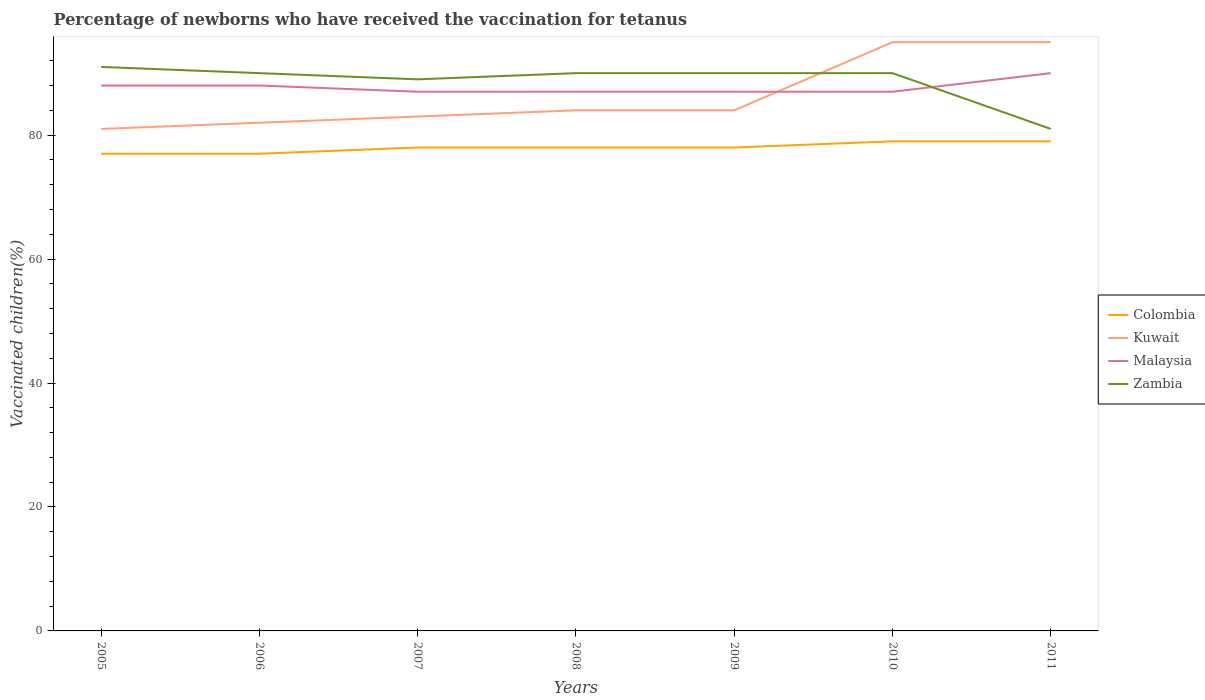Is the number of lines equal to the number of legend labels?
Keep it short and to the point. Yes. What is the total percentage of vaccinated children in Zambia in the graph?
Keep it short and to the point. 9. What is the difference between the highest and the second highest percentage of vaccinated children in Colombia?
Give a very brief answer. 2. Is the percentage of vaccinated children in Malaysia strictly greater than the percentage of vaccinated children in Colombia over the years?
Make the answer very short. No. How many years are there in the graph?
Keep it short and to the point. 7. What is the difference between two consecutive major ticks on the Y-axis?
Give a very brief answer. 20. Are the values on the major ticks of Y-axis written in scientific E-notation?
Offer a very short reply. No. Does the graph contain any zero values?
Offer a terse response. No. Does the graph contain grids?
Your answer should be very brief. No. How are the legend labels stacked?
Your answer should be compact. Vertical. What is the title of the graph?
Offer a terse response. Percentage of newborns who have received the vaccination for tetanus. What is the label or title of the Y-axis?
Offer a very short reply. Vaccinated children(%). What is the Vaccinated children(%) in Colombia in 2005?
Offer a very short reply. 77. What is the Vaccinated children(%) in Kuwait in 2005?
Make the answer very short. 81. What is the Vaccinated children(%) of Zambia in 2005?
Offer a very short reply. 91. What is the Vaccinated children(%) in Malaysia in 2006?
Offer a terse response. 88. What is the Vaccinated children(%) in Zambia in 2006?
Your answer should be compact. 90. What is the Vaccinated children(%) of Colombia in 2007?
Provide a succinct answer. 78. What is the Vaccinated children(%) of Kuwait in 2007?
Make the answer very short. 83. What is the Vaccinated children(%) in Zambia in 2007?
Give a very brief answer. 89. What is the Vaccinated children(%) in Kuwait in 2008?
Your answer should be compact. 84. What is the Vaccinated children(%) of Malaysia in 2008?
Make the answer very short. 87. What is the Vaccinated children(%) of Colombia in 2009?
Provide a succinct answer. 78. What is the Vaccinated children(%) in Kuwait in 2009?
Your answer should be very brief. 84. What is the Vaccinated children(%) of Malaysia in 2009?
Your response must be concise. 87. What is the Vaccinated children(%) of Zambia in 2009?
Offer a very short reply. 90. What is the Vaccinated children(%) in Colombia in 2010?
Offer a very short reply. 79. What is the Vaccinated children(%) of Colombia in 2011?
Offer a terse response. 79. What is the Vaccinated children(%) of Zambia in 2011?
Give a very brief answer. 81. Across all years, what is the maximum Vaccinated children(%) in Colombia?
Provide a short and direct response. 79. Across all years, what is the maximum Vaccinated children(%) of Malaysia?
Provide a short and direct response. 90. Across all years, what is the maximum Vaccinated children(%) of Zambia?
Your answer should be very brief. 91. Across all years, what is the minimum Vaccinated children(%) in Kuwait?
Offer a very short reply. 81. Across all years, what is the minimum Vaccinated children(%) in Malaysia?
Keep it short and to the point. 87. Across all years, what is the minimum Vaccinated children(%) in Zambia?
Offer a very short reply. 81. What is the total Vaccinated children(%) of Colombia in the graph?
Your response must be concise. 546. What is the total Vaccinated children(%) of Kuwait in the graph?
Your answer should be very brief. 604. What is the total Vaccinated children(%) of Malaysia in the graph?
Provide a short and direct response. 614. What is the total Vaccinated children(%) of Zambia in the graph?
Offer a very short reply. 621. What is the difference between the Vaccinated children(%) of Malaysia in 2005 and that in 2006?
Provide a short and direct response. 0. What is the difference between the Vaccinated children(%) in Zambia in 2005 and that in 2006?
Give a very brief answer. 1. What is the difference between the Vaccinated children(%) of Kuwait in 2005 and that in 2007?
Provide a succinct answer. -2. What is the difference between the Vaccinated children(%) in Zambia in 2005 and that in 2007?
Your answer should be compact. 2. What is the difference between the Vaccinated children(%) in Colombia in 2005 and that in 2008?
Your answer should be compact. -1. What is the difference between the Vaccinated children(%) of Kuwait in 2005 and that in 2008?
Your answer should be very brief. -3. What is the difference between the Vaccinated children(%) of Zambia in 2005 and that in 2008?
Your answer should be very brief. 1. What is the difference between the Vaccinated children(%) of Colombia in 2005 and that in 2009?
Your answer should be compact. -1. What is the difference between the Vaccinated children(%) of Colombia in 2005 and that in 2010?
Offer a very short reply. -2. What is the difference between the Vaccinated children(%) of Zambia in 2005 and that in 2010?
Give a very brief answer. 1. What is the difference between the Vaccinated children(%) of Malaysia in 2005 and that in 2011?
Offer a terse response. -2. What is the difference between the Vaccinated children(%) of Zambia in 2005 and that in 2011?
Provide a succinct answer. 10. What is the difference between the Vaccinated children(%) of Zambia in 2006 and that in 2007?
Ensure brevity in your answer.  1. What is the difference between the Vaccinated children(%) of Malaysia in 2006 and that in 2008?
Keep it short and to the point. 1. What is the difference between the Vaccinated children(%) of Zambia in 2006 and that in 2008?
Your answer should be very brief. 0. What is the difference between the Vaccinated children(%) of Colombia in 2006 and that in 2009?
Your answer should be very brief. -1. What is the difference between the Vaccinated children(%) in Zambia in 2006 and that in 2009?
Your answer should be compact. 0. What is the difference between the Vaccinated children(%) in Malaysia in 2006 and that in 2010?
Keep it short and to the point. 1. What is the difference between the Vaccinated children(%) of Colombia in 2006 and that in 2011?
Ensure brevity in your answer.  -2. What is the difference between the Vaccinated children(%) of Malaysia in 2006 and that in 2011?
Make the answer very short. -2. What is the difference between the Vaccinated children(%) in Zambia in 2006 and that in 2011?
Offer a terse response. 9. What is the difference between the Vaccinated children(%) in Colombia in 2007 and that in 2008?
Your answer should be very brief. 0. What is the difference between the Vaccinated children(%) in Kuwait in 2007 and that in 2008?
Provide a succinct answer. -1. What is the difference between the Vaccinated children(%) of Zambia in 2007 and that in 2008?
Your response must be concise. -1. What is the difference between the Vaccinated children(%) in Kuwait in 2007 and that in 2009?
Provide a succinct answer. -1. What is the difference between the Vaccinated children(%) in Malaysia in 2007 and that in 2010?
Ensure brevity in your answer.  0. What is the difference between the Vaccinated children(%) of Zambia in 2007 and that in 2010?
Give a very brief answer. -1. What is the difference between the Vaccinated children(%) of Malaysia in 2007 and that in 2011?
Your answer should be compact. -3. What is the difference between the Vaccinated children(%) in Zambia in 2007 and that in 2011?
Your answer should be compact. 8. What is the difference between the Vaccinated children(%) of Colombia in 2008 and that in 2009?
Offer a very short reply. 0. What is the difference between the Vaccinated children(%) of Malaysia in 2008 and that in 2009?
Your answer should be compact. 0. What is the difference between the Vaccinated children(%) of Colombia in 2008 and that in 2010?
Offer a very short reply. -1. What is the difference between the Vaccinated children(%) of Kuwait in 2008 and that in 2010?
Your response must be concise. -11. What is the difference between the Vaccinated children(%) in Kuwait in 2008 and that in 2011?
Give a very brief answer. -11. What is the difference between the Vaccinated children(%) of Malaysia in 2008 and that in 2011?
Provide a succinct answer. -3. What is the difference between the Vaccinated children(%) of Kuwait in 2009 and that in 2010?
Provide a short and direct response. -11. What is the difference between the Vaccinated children(%) of Malaysia in 2009 and that in 2010?
Ensure brevity in your answer.  0. What is the difference between the Vaccinated children(%) of Zambia in 2009 and that in 2010?
Offer a very short reply. 0. What is the difference between the Vaccinated children(%) of Colombia in 2009 and that in 2011?
Your answer should be compact. -1. What is the difference between the Vaccinated children(%) of Malaysia in 2010 and that in 2011?
Ensure brevity in your answer.  -3. What is the difference between the Vaccinated children(%) of Colombia in 2005 and the Vaccinated children(%) of Malaysia in 2006?
Your answer should be very brief. -11. What is the difference between the Vaccinated children(%) of Kuwait in 2005 and the Vaccinated children(%) of Malaysia in 2006?
Provide a succinct answer. -7. What is the difference between the Vaccinated children(%) in Colombia in 2005 and the Vaccinated children(%) in Kuwait in 2007?
Your answer should be very brief. -6. What is the difference between the Vaccinated children(%) of Colombia in 2005 and the Vaccinated children(%) of Malaysia in 2007?
Keep it short and to the point. -10. What is the difference between the Vaccinated children(%) in Colombia in 2005 and the Vaccinated children(%) in Zambia in 2007?
Offer a very short reply. -12. What is the difference between the Vaccinated children(%) of Kuwait in 2005 and the Vaccinated children(%) of Malaysia in 2007?
Give a very brief answer. -6. What is the difference between the Vaccinated children(%) in Colombia in 2005 and the Vaccinated children(%) in Malaysia in 2008?
Keep it short and to the point. -10. What is the difference between the Vaccinated children(%) of Malaysia in 2005 and the Vaccinated children(%) of Zambia in 2008?
Your response must be concise. -2. What is the difference between the Vaccinated children(%) of Kuwait in 2005 and the Vaccinated children(%) of Zambia in 2009?
Offer a terse response. -9. What is the difference between the Vaccinated children(%) in Colombia in 2005 and the Vaccinated children(%) in Kuwait in 2010?
Make the answer very short. -18. What is the difference between the Vaccinated children(%) in Colombia in 2005 and the Vaccinated children(%) in Malaysia in 2010?
Make the answer very short. -10. What is the difference between the Vaccinated children(%) in Colombia in 2005 and the Vaccinated children(%) in Zambia in 2010?
Keep it short and to the point. -13. What is the difference between the Vaccinated children(%) in Kuwait in 2005 and the Vaccinated children(%) in Zambia in 2010?
Offer a terse response. -9. What is the difference between the Vaccinated children(%) in Colombia in 2005 and the Vaccinated children(%) in Kuwait in 2011?
Provide a short and direct response. -18. What is the difference between the Vaccinated children(%) in Malaysia in 2005 and the Vaccinated children(%) in Zambia in 2011?
Your answer should be very brief. 7. What is the difference between the Vaccinated children(%) of Colombia in 2006 and the Vaccinated children(%) of Malaysia in 2007?
Keep it short and to the point. -10. What is the difference between the Vaccinated children(%) in Colombia in 2006 and the Vaccinated children(%) in Zambia in 2007?
Offer a very short reply. -12. What is the difference between the Vaccinated children(%) of Kuwait in 2006 and the Vaccinated children(%) of Zambia in 2007?
Your answer should be compact. -7. What is the difference between the Vaccinated children(%) in Colombia in 2006 and the Vaccinated children(%) in Malaysia in 2008?
Keep it short and to the point. -10. What is the difference between the Vaccinated children(%) in Kuwait in 2006 and the Vaccinated children(%) in Zambia in 2008?
Your response must be concise. -8. What is the difference between the Vaccinated children(%) in Colombia in 2006 and the Vaccinated children(%) in Malaysia in 2009?
Give a very brief answer. -10. What is the difference between the Vaccinated children(%) in Kuwait in 2006 and the Vaccinated children(%) in Malaysia in 2009?
Keep it short and to the point. -5. What is the difference between the Vaccinated children(%) of Kuwait in 2006 and the Vaccinated children(%) of Zambia in 2009?
Your response must be concise. -8. What is the difference between the Vaccinated children(%) of Colombia in 2006 and the Vaccinated children(%) of Zambia in 2010?
Provide a succinct answer. -13. What is the difference between the Vaccinated children(%) in Colombia in 2006 and the Vaccinated children(%) in Kuwait in 2011?
Your answer should be compact. -18. What is the difference between the Vaccinated children(%) in Colombia in 2006 and the Vaccinated children(%) in Malaysia in 2011?
Give a very brief answer. -13. What is the difference between the Vaccinated children(%) in Malaysia in 2007 and the Vaccinated children(%) in Zambia in 2008?
Your response must be concise. -3. What is the difference between the Vaccinated children(%) in Colombia in 2007 and the Vaccinated children(%) in Kuwait in 2009?
Provide a succinct answer. -6. What is the difference between the Vaccinated children(%) in Kuwait in 2007 and the Vaccinated children(%) in Zambia in 2009?
Provide a succinct answer. -7. What is the difference between the Vaccinated children(%) in Malaysia in 2007 and the Vaccinated children(%) in Zambia in 2009?
Your answer should be very brief. -3. What is the difference between the Vaccinated children(%) of Colombia in 2007 and the Vaccinated children(%) of Malaysia in 2010?
Provide a short and direct response. -9. What is the difference between the Vaccinated children(%) in Colombia in 2007 and the Vaccinated children(%) in Kuwait in 2011?
Ensure brevity in your answer.  -17. What is the difference between the Vaccinated children(%) of Colombia in 2007 and the Vaccinated children(%) of Malaysia in 2011?
Provide a short and direct response. -12. What is the difference between the Vaccinated children(%) of Colombia in 2007 and the Vaccinated children(%) of Zambia in 2011?
Give a very brief answer. -3. What is the difference between the Vaccinated children(%) in Kuwait in 2007 and the Vaccinated children(%) in Zambia in 2011?
Offer a very short reply. 2. What is the difference between the Vaccinated children(%) of Malaysia in 2007 and the Vaccinated children(%) of Zambia in 2011?
Your answer should be very brief. 6. What is the difference between the Vaccinated children(%) in Colombia in 2008 and the Vaccinated children(%) in Zambia in 2009?
Ensure brevity in your answer.  -12. What is the difference between the Vaccinated children(%) of Kuwait in 2008 and the Vaccinated children(%) of Malaysia in 2009?
Give a very brief answer. -3. What is the difference between the Vaccinated children(%) of Colombia in 2008 and the Vaccinated children(%) of Zambia in 2010?
Offer a very short reply. -12. What is the difference between the Vaccinated children(%) in Kuwait in 2008 and the Vaccinated children(%) in Malaysia in 2010?
Offer a very short reply. -3. What is the difference between the Vaccinated children(%) in Malaysia in 2008 and the Vaccinated children(%) in Zambia in 2010?
Your answer should be compact. -3. What is the difference between the Vaccinated children(%) in Kuwait in 2008 and the Vaccinated children(%) in Zambia in 2011?
Your response must be concise. 3. What is the difference between the Vaccinated children(%) of Colombia in 2009 and the Vaccinated children(%) of Kuwait in 2010?
Your answer should be very brief. -17. What is the difference between the Vaccinated children(%) of Colombia in 2009 and the Vaccinated children(%) of Malaysia in 2010?
Offer a very short reply. -9. What is the difference between the Vaccinated children(%) of Colombia in 2009 and the Vaccinated children(%) of Zambia in 2010?
Give a very brief answer. -12. What is the difference between the Vaccinated children(%) in Kuwait in 2009 and the Vaccinated children(%) in Malaysia in 2010?
Provide a short and direct response. -3. What is the difference between the Vaccinated children(%) of Kuwait in 2009 and the Vaccinated children(%) of Zambia in 2010?
Give a very brief answer. -6. What is the difference between the Vaccinated children(%) in Malaysia in 2009 and the Vaccinated children(%) in Zambia in 2010?
Offer a very short reply. -3. What is the difference between the Vaccinated children(%) in Colombia in 2009 and the Vaccinated children(%) in Kuwait in 2011?
Keep it short and to the point. -17. What is the difference between the Vaccinated children(%) of Colombia in 2009 and the Vaccinated children(%) of Malaysia in 2011?
Offer a terse response. -12. What is the difference between the Vaccinated children(%) of Colombia in 2010 and the Vaccinated children(%) of Kuwait in 2011?
Ensure brevity in your answer.  -16. What is the difference between the Vaccinated children(%) in Colombia in 2010 and the Vaccinated children(%) in Malaysia in 2011?
Your answer should be very brief. -11. What is the difference between the Vaccinated children(%) in Colombia in 2010 and the Vaccinated children(%) in Zambia in 2011?
Make the answer very short. -2. What is the difference between the Vaccinated children(%) of Kuwait in 2010 and the Vaccinated children(%) of Malaysia in 2011?
Ensure brevity in your answer.  5. What is the difference between the Vaccinated children(%) of Kuwait in 2010 and the Vaccinated children(%) of Zambia in 2011?
Provide a short and direct response. 14. What is the average Vaccinated children(%) of Colombia per year?
Offer a terse response. 78. What is the average Vaccinated children(%) in Kuwait per year?
Provide a short and direct response. 86.29. What is the average Vaccinated children(%) in Malaysia per year?
Your answer should be very brief. 87.71. What is the average Vaccinated children(%) in Zambia per year?
Your response must be concise. 88.71. In the year 2005, what is the difference between the Vaccinated children(%) of Colombia and Vaccinated children(%) of Kuwait?
Ensure brevity in your answer.  -4. In the year 2005, what is the difference between the Vaccinated children(%) in Kuwait and Vaccinated children(%) in Zambia?
Ensure brevity in your answer.  -10. In the year 2005, what is the difference between the Vaccinated children(%) in Malaysia and Vaccinated children(%) in Zambia?
Your response must be concise. -3. In the year 2006, what is the difference between the Vaccinated children(%) in Colombia and Vaccinated children(%) in Kuwait?
Ensure brevity in your answer.  -5. In the year 2006, what is the difference between the Vaccinated children(%) in Colombia and Vaccinated children(%) in Zambia?
Your answer should be very brief. -13. In the year 2006, what is the difference between the Vaccinated children(%) of Kuwait and Vaccinated children(%) of Zambia?
Ensure brevity in your answer.  -8. In the year 2006, what is the difference between the Vaccinated children(%) in Malaysia and Vaccinated children(%) in Zambia?
Offer a terse response. -2. In the year 2007, what is the difference between the Vaccinated children(%) of Colombia and Vaccinated children(%) of Kuwait?
Offer a very short reply. -5. In the year 2007, what is the difference between the Vaccinated children(%) in Colombia and Vaccinated children(%) in Malaysia?
Provide a succinct answer. -9. In the year 2007, what is the difference between the Vaccinated children(%) of Kuwait and Vaccinated children(%) of Zambia?
Your response must be concise. -6. In the year 2007, what is the difference between the Vaccinated children(%) of Malaysia and Vaccinated children(%) of Zambia?
Give a very brief answer. -2. In the year 2008, what is the difference between the Vaccinated children(%) in Colombia and Vaccinated children(%) in Zambia?
Provide a short and direct response. -12. In the year 2008, what is the difference between the Vaccinated children(%) in Malaysia and Vaccinated children(%) in Zambia?
Keep it short and to the point. -3. In the year 2009, what is the difference between the Vaccinated children(%) of Colombia and Vaccinated children(%) of Malaysia?
Ensure brevity in your answer.  -9. In the year 2009, what is the difference between the Vaccinated children(%) of Kuwait and Vaccinated children(%) of Malaysia?
Provide a succinct answer. -3. In the year 2010, what is the difference between the Vaccinated children(%) of Colombia and Vaccinated children(%) of Malaysia?
Give a very brief answer. -8. In the year 2010, what is the difference between the Vaccinated children(%) in Kuwait and Vaccinated children(%) in Malaysia?
Keep it short and to the point. 8. In the year 2010, what is the difference between the Vaccinated children(%) in Kuwait and Vaccinated children(%) in Zambia?
Offer a very short reply. 5. In the year 2010, what is the difference between the Vaccinated children(%) in Malaysia and Vaccinated children(%) in Zambia?
Keep it short and to the point. -3. In the year 2011, what is the difference between the Vaccinated children(%) in Colombia and Vaccinated children(%) in Kuwait?
Offer a very short reply. -16. In the year 2011, what is the difference between the Vaccinated children(%) of Colombia and Vaccinated children(%) of Zambia?
Your answer should be compact. -2. In the year 2011, what is the difference between the Vaccinated children(%) of Malaysia and Vaccinated children(%) of Zambia?
Give a very brief answer. 9. What is the ratio of the Vaccinated children(%) in Kuwait in 2005 to that in 2006?
Make the answer very short. 0.99. What is the ratio of the Vaccinated children(%) in Zambia in 2005 to that in 2006?
Keep it short and to the point. 1.01. What is the ratio of the Vaccinated children(%) of Colombia in 2005 to that in 2007?
Keep it short and to the point. 0.99. What is the ratio of the Vaccinated children(%) in Kuwait in 2005 to that in 2007?
Your response must be concise. 0.98. What is the ratio of the Vaccinated children(%) of Malaysia in 2005 to that in 2007?
Your answer should be compact. 1.01. What is the ratio of the Vaccinated children(%) of Zambia in 2005 to that in 2007?
Your answer should be compact. 1.02. What is the ratio of the Vaccinated children(%) of Colombia in 2005 to that in 2008?
Give a very brief answer. 0.99. What is the ratio of the Vaccinated children(%) of Malaysia in 2005 to that in 2008?
Offer a terse response. 1.01. What is the ratio of the Vaccinated children(%) in Zambia in 2005 to that in 2008?
Offer a very short reply. 1.01. What is the ratio of the Vaccinated children(%) in Colombia in 2005 to that in 2009?
Provide a succinct answer. 0.99. What is the ratio of the Vaccinated children(%) in Malaysia in 2005 to that in 2009?
Offer a terse response. 1.01. What is the ratio of the Vaccinated children(%) of Zambia in 2005 to that in 2009?
Provide a succinct answer. 1.01. What is the ratio of the Vaccinated children(%) in Colombia in 2005 to that in 2010?
Keep it short and to the point. 0.97. What is the ratio of the Vaccinated children(%) in Kuwait in 2005 to that in 2010?
Your response must be concise. 0.85. What is the ratio of the Vaccinated children(%) in Malaysia in 2005 to that in 2010?
Give a very brief answer. 1.01. What is the ratio of the Vaccinated children(%) in Zambia in 2005 to that in 2010?
Keep it short and to the point. 1.01. What is the ratio of the Vaccinated children(%) in Colombia in 2005 to that in 2011?
Your answer should be compact. 0.97. What is the ratio of the Vaccinated children(%) of Kuwait in 2005 to that in 2011?
Make the answer very short. 0.85. What is the ratio of the Vaccinated children(%) of Malaysia in 2005 to that in 2011?
Offer a very short reply. 0.98. What is the ratio of the Vaccinated children(%) in Zambia in 2005 to that in 2011?
Provide a succinct answer. 1.12. What is the ratio of the Vaccinated children(%) in Colombia in 2006 to that in 2007?
Provide a short and direct response. 0.99. What is the ratio of the Vaccinated children(%) of Malaysia in 2006 to that in 2007?
Your answer should be compact. 1.01. What is the ratio of the Vaccinated children(%) in Zambia in 2006 to that in 2007?
Keep it short and to the point. 1.01. What is the ratio of the Vaccinated children(%) of Colombia in 2006 to that in 2008?
Provide a succinct answer. 0.99. What is the ratio of the Vaccinated children(%) in Kuwait in 2006 to that in 2008?
Make the answer very short. 0.98. What is the ratio of the Vaccinated children(%) in Malaysia in 2006 to that in 2008?
Give a very brief answer. 1.01. What is the ratio of the Vaccinated children(%) of Zambia in 2006 to that in 2008?
Provide a short and direct response. 1. What is the ratio of the Vaccinated children(%) of Colombia in 2006 to that in 2009?
Make the answer very short. 0.99. What is the ratio of the Vaccinated children(%) of Kuwait in 2006 to that in 2009?
Make the answer very short. 0.98. What is the ratio of the Vaccinated children(%) of Malaysia in 2006 to that in 2009?
Ensure brevity in your answer.  1.01. What is the ratio of the Vaccinated children(%) in Colombia in 2006 to that in 2010?
Ensure brevity in your answer.  0.97. What is the ratio of the Vaccinated children(%) of Kuwait in 2006 to that in 2010?
Provide a short and direct response. 0.86. What is the ratio of the Vaccinated children(%) of Malaysia in 2006 to that in 2010?
Provide a short and direct response. 1.01. What is the ratio of the Vaccinated children(%) in Colombia in 2006 to that in 2011?
Offer a very short reply. 0.97. What is the ratio of the Vaccinated children(%) in Kuwait in 2006 to that in 2011?
Your answer should be very brief. 0.86. What is the ratio of the Vaccinated children(%) in Malaysia in 2006 to that in 2011?
Provide a succinct answer. 0.98. What is the ratio of the Vaccinated children(%) in Zambia in 2006 to that in 2011?
Ensure brevity in your answer.  1.11. What is the ratio of the Vaccinated children(%) of Zambia in 2007 to that in 2008?
Your response must be concise. 0.99. What is the ratio of the Vaccinated children(%) of Colombia in 2007 to that in 2009?
Make the answer very short. 1. What is the ratio of the Vaccinated children(%) in Malaysia in 2007 to that in 2009?
Your answer should be compact. 1. What is the ratio of the Vaccinated children(%) in Zambia in 2007 to that in 2009?
Provide a short and direct response. 0.99. What is the ratio of the Vaccinated children(%) of Colombia in 2007 to that in 2010?
Keep it short and to the point. 0.99. What is the ratio of the Vaccinated children(%) of Kuwait in 2007 to that in 2010?
Your answer should be compact. 0.87. What is the ratio of the Vaccinated children(%) in Zambia in 2007 to that in 2010?
Your answer should be very brief. 0.99. What is the ratio of the Vaccinated children(%) of Colombia in 2007 to that in 2011?
Give a very brief answer. 0.99. What is the ratio of the Vaccinated children(%) in Kuwait in 2007 to that in 2011?
Make the answer very short. 0.87. What is the ratio of the Vaccinated children(%) of Malaysia in 2007 to that in 2011?
Provide a succinct answer. 0.97. What is the ratio of the Vaccinated children(%) of Zambia in 2007 to that in 2011?
Provide a succinct answer. 1.1. What is the ratio of the Vaccinated children(%) in Colombia in 2008 to that in 2009?
Keep it short and to the point. 1. What is the ratio of the Vaccinated children(%) of Kuwait in 2008 to that in 2009?
Offer a very short reply. 1. What is the ratio of the Vaccinated children(%) of Malaysia in 2008 to that in 2009?
Provide a short and direct response. 1. What is the ratio of the Vaccinated children(%) in Colombia in 2008 to that in 2010?
Ensure brevity in your answer.  0.99. What is the ratio of the Vaccinated children(%) of Kuwait in 2008 to that in 2010?
Ensure brevity in your answer.  0.88. What is the ratio of the Vaccinated children(%) in Malaysia in 2008 to that in 2010?
Offer a very short reply. 1. What is the ratio of the Vaccinated children(%) in Zambia in 2008 to that in 2010?
Provide a short and direct response. 1. What is the ratio of the Vaccinated children(%) of Colombia in 2008 to that in 2011?
Provide a succinct answer. 0.99. What is the ratio of the Vaccinated children(%) in Kuwait in 2008 to that in 2011?
Keep it short and to the point. 0.88. What is the ratio of the Vaccinated children(%) in Malaysia in 2008 to that in 2011?
Keep it short and to the point. 0.97. What is the ratio of the Vaccinated children(%) of Colombia in 2009 to that in 2010?
Provide a short and direct response. 0.99. What is the ratio of the Vaccinated children(%) in Kuwait in 2009 to that in 2010?
Provide a succinct answer. 0.88. What is the ratio of the Vaccinated children(%) in Colombia in 2009 to that in 2011?
Provide a short and direct response. 0.99. What is the ratio of the Vaccinated children(%) of Kuwait in 2009 to that in 2011?
Ensure brevity in your answer.  0.88. What is the ratio of the Vaccinated children(%) in Malaysia in 2009 to that in 2011?
Give a very brief answer. 0.97. What is the ratio of the Vaccinated children(%) in Colombia in 2010 to that in 2011?
Make the answer very short. 1. What is the ratio of the Vaccinated children(%) of Malaysia in 2010 to that in 2011?
Your answer should be very brief. 0.97. What is the difference between the highest and the second highest Vaccinated children(%) in Zambia?
Provide a short and direct response. 1. What is the difference between the highest and the lowest Vaccinated children(%) of Colombia?
Ensure brevity in your answer.  2. What is the difference between the highest and the lowest Vaccinated children(%) in Kuwait?
Ensure brevity in your answer.  14. 